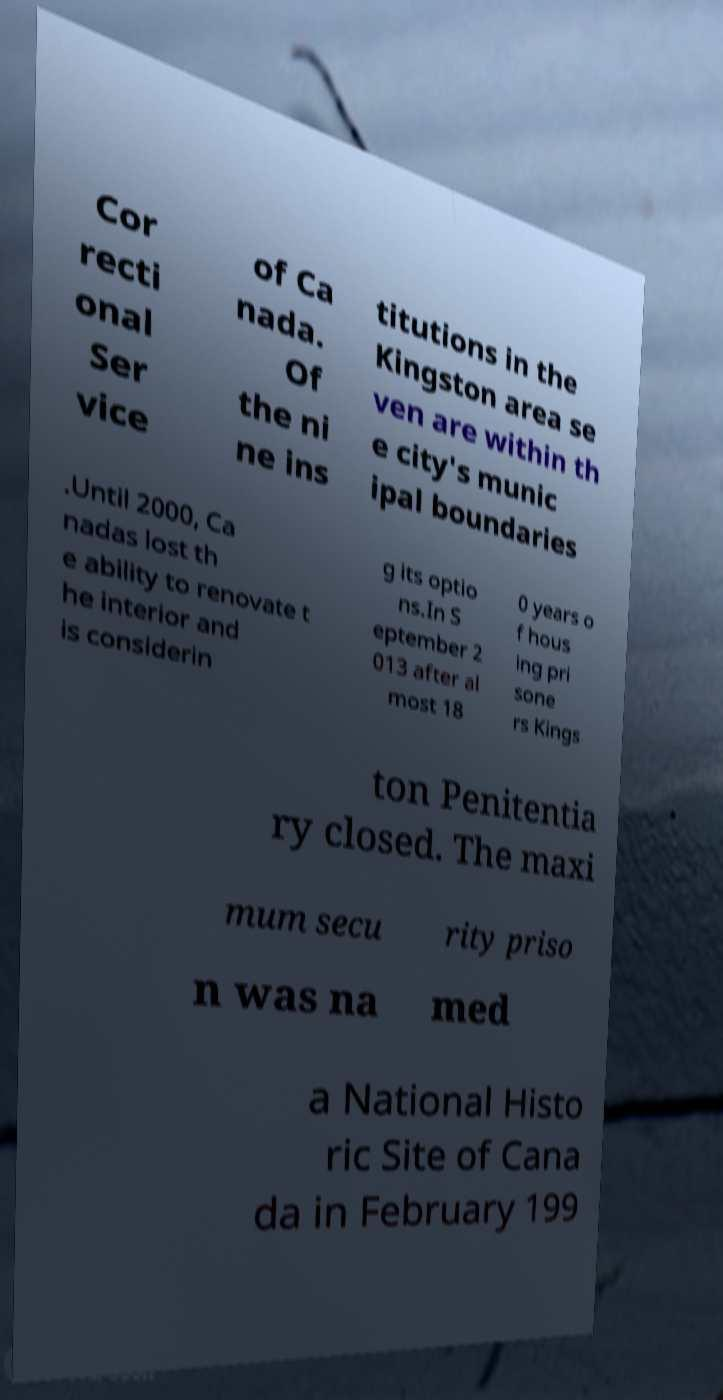Could you assist in decoding the text presented in this image and type it out clearly? Cor recti onal Ser vice of Ca nada. Of the ni ne ins titutions in the Kingston area se ven are within th e city's munic ipal boundaries .Until 2000, Ca nadas lost th e ability to renovate t he interior and is considerin g its optio ns.In S eptember 2 013 after al most 18 0 years o f hous ing pri sone rs Kings ton Penitentia ry closed. The maxi mum secu rity priso n was na med a National Histo ric Site of Cana da in February 199 